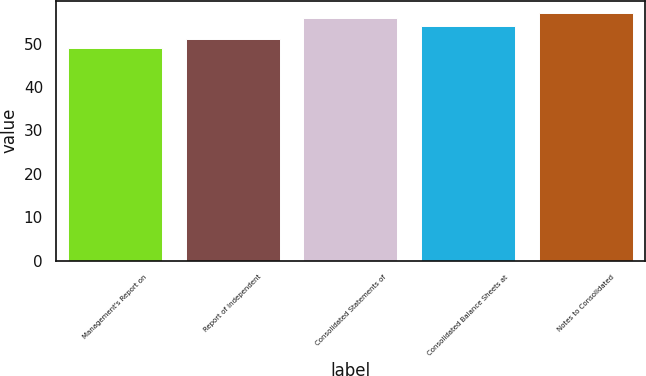Convert chart to OTSL. <chart><loc_0><loc_0><loc_500><loc_500><bar_chart><fcel>Management's Report on<fcel>Report of Independent<fcel>Consolidated Statements of<fcel>Consolidated Balance Sheets at<fcel>Notes to Consolidated<nl><fcel>49<fcel>51<fcel>56<fcel>54<fcel>57<nl></chart> 